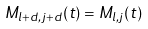<formula> <loc_0><loc_0><loc_500><loc_500>M _ { l + d , j + d } ( t ) = M _ { l , j } ( t )</formula> 